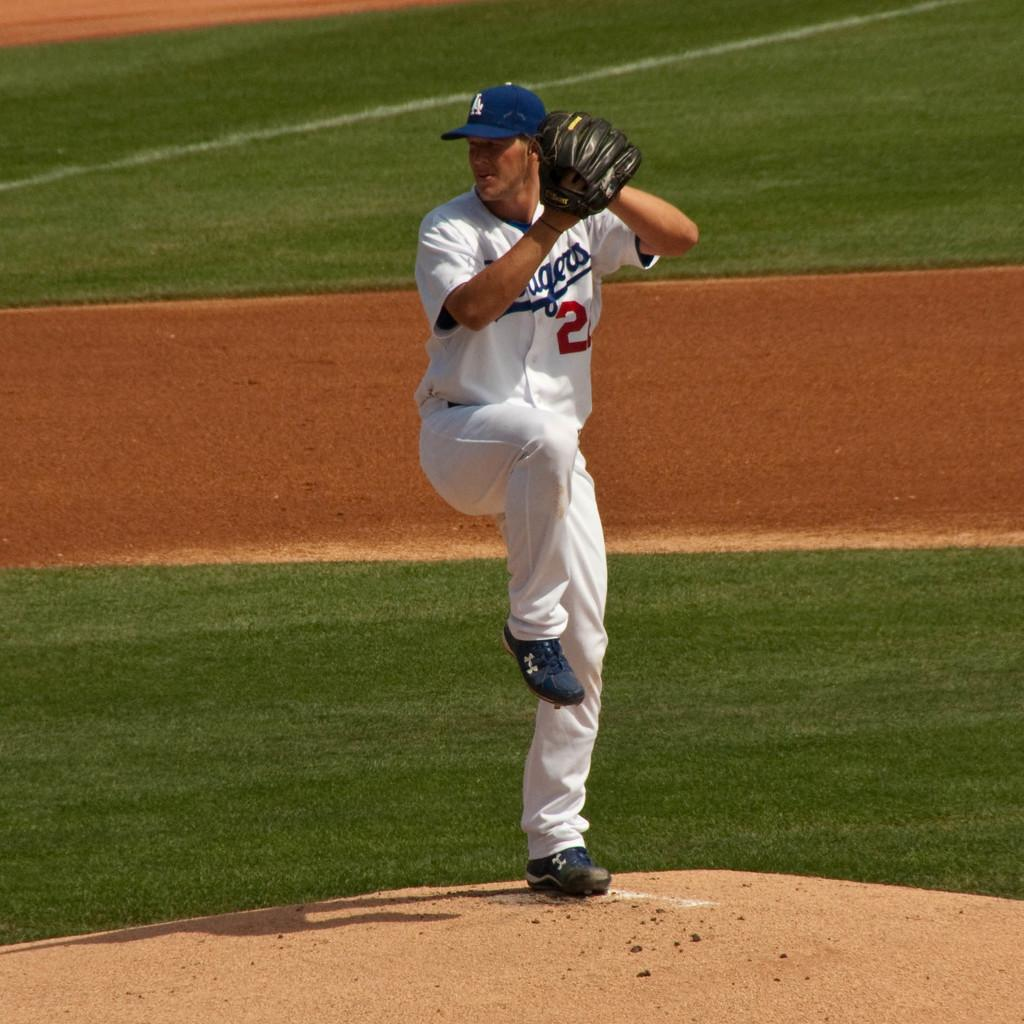<image>
Give a short and clear explanation of the subsequent image. A baseball player with the number 2 on his jersey. 